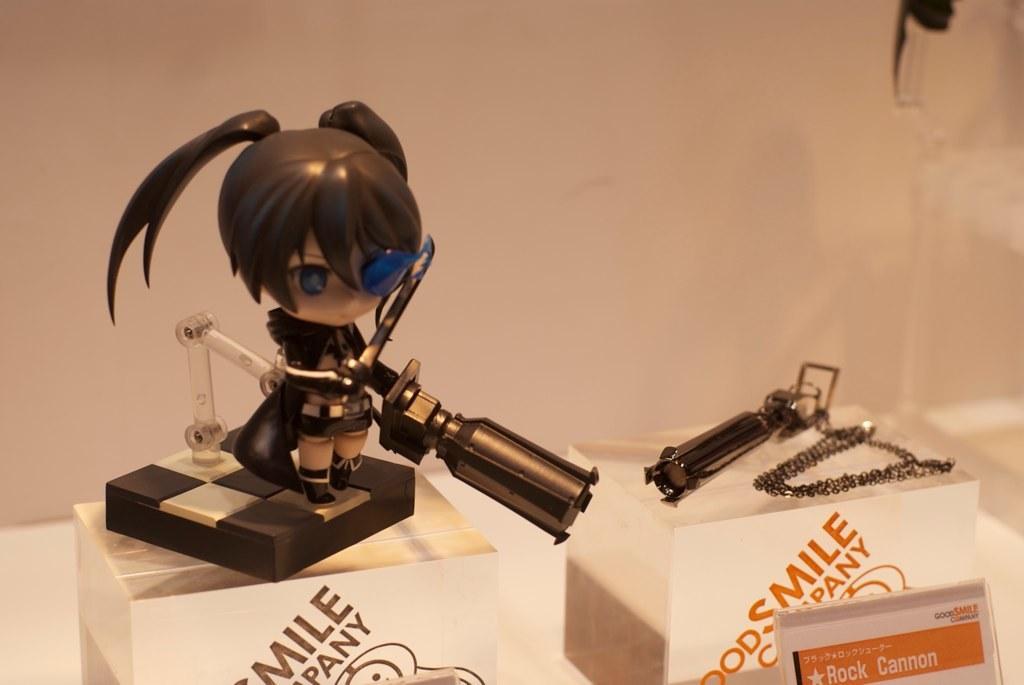Can you describe this image briefly? In the picture we can see some animated toy picture. 